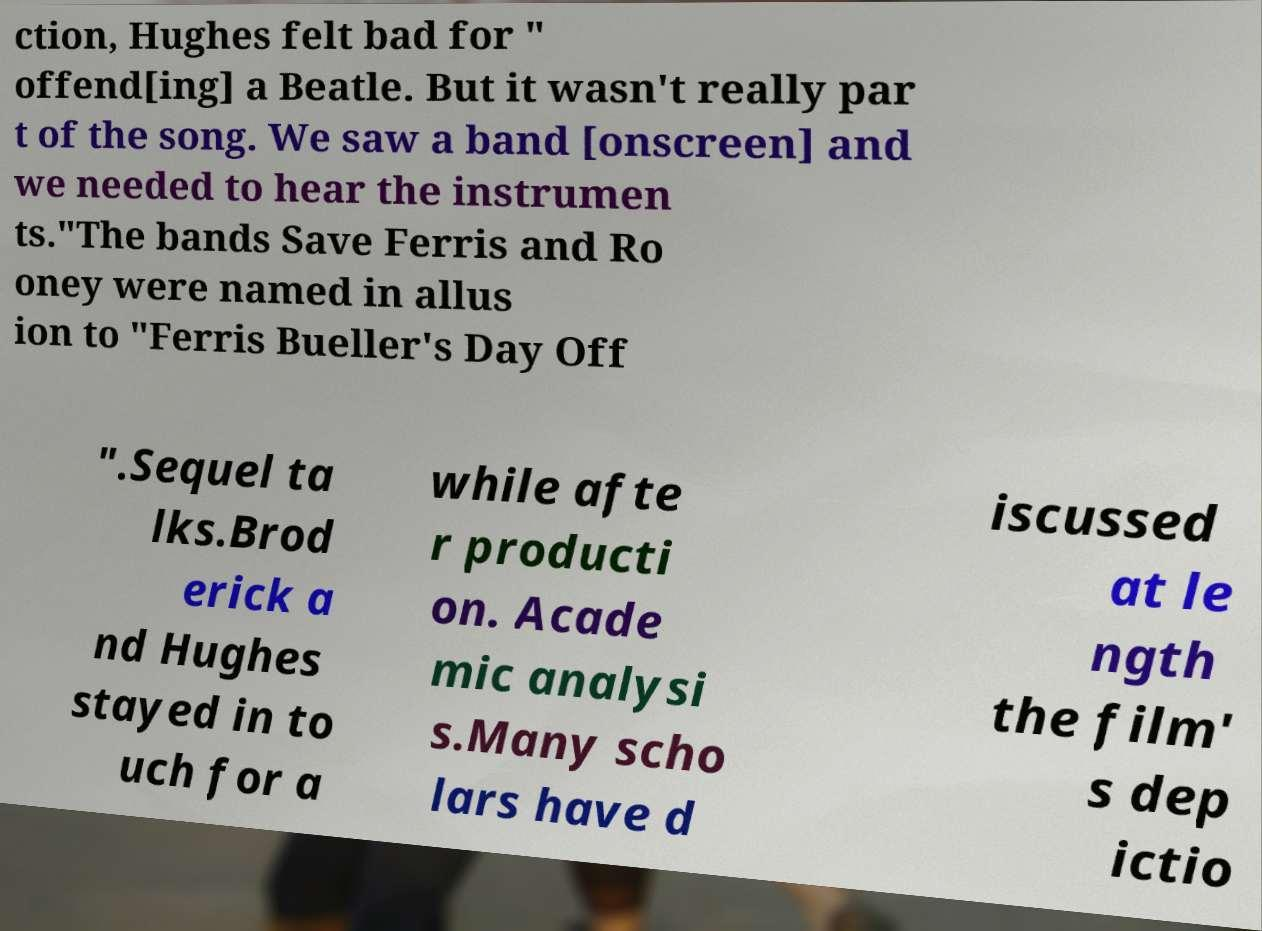I need the written content from this picture converted into text. Can you do that? ction, Hughes felt bad for " offend[ing] a Beatle. But it wasn't really par t of the song. We saw a band [onscreen] and we needed to hear the instrumen ts."The bands Save Ferris and Ro oney were named in allus ion to "Ferris Bueller's Day Off ".Sequel ta lks.Brod erick a nd Hughes stayed in to uch for a while afte r producti on. Acade mic analysi s.Many scho lars have d iscussed at le ngth the film' s dep ictio 